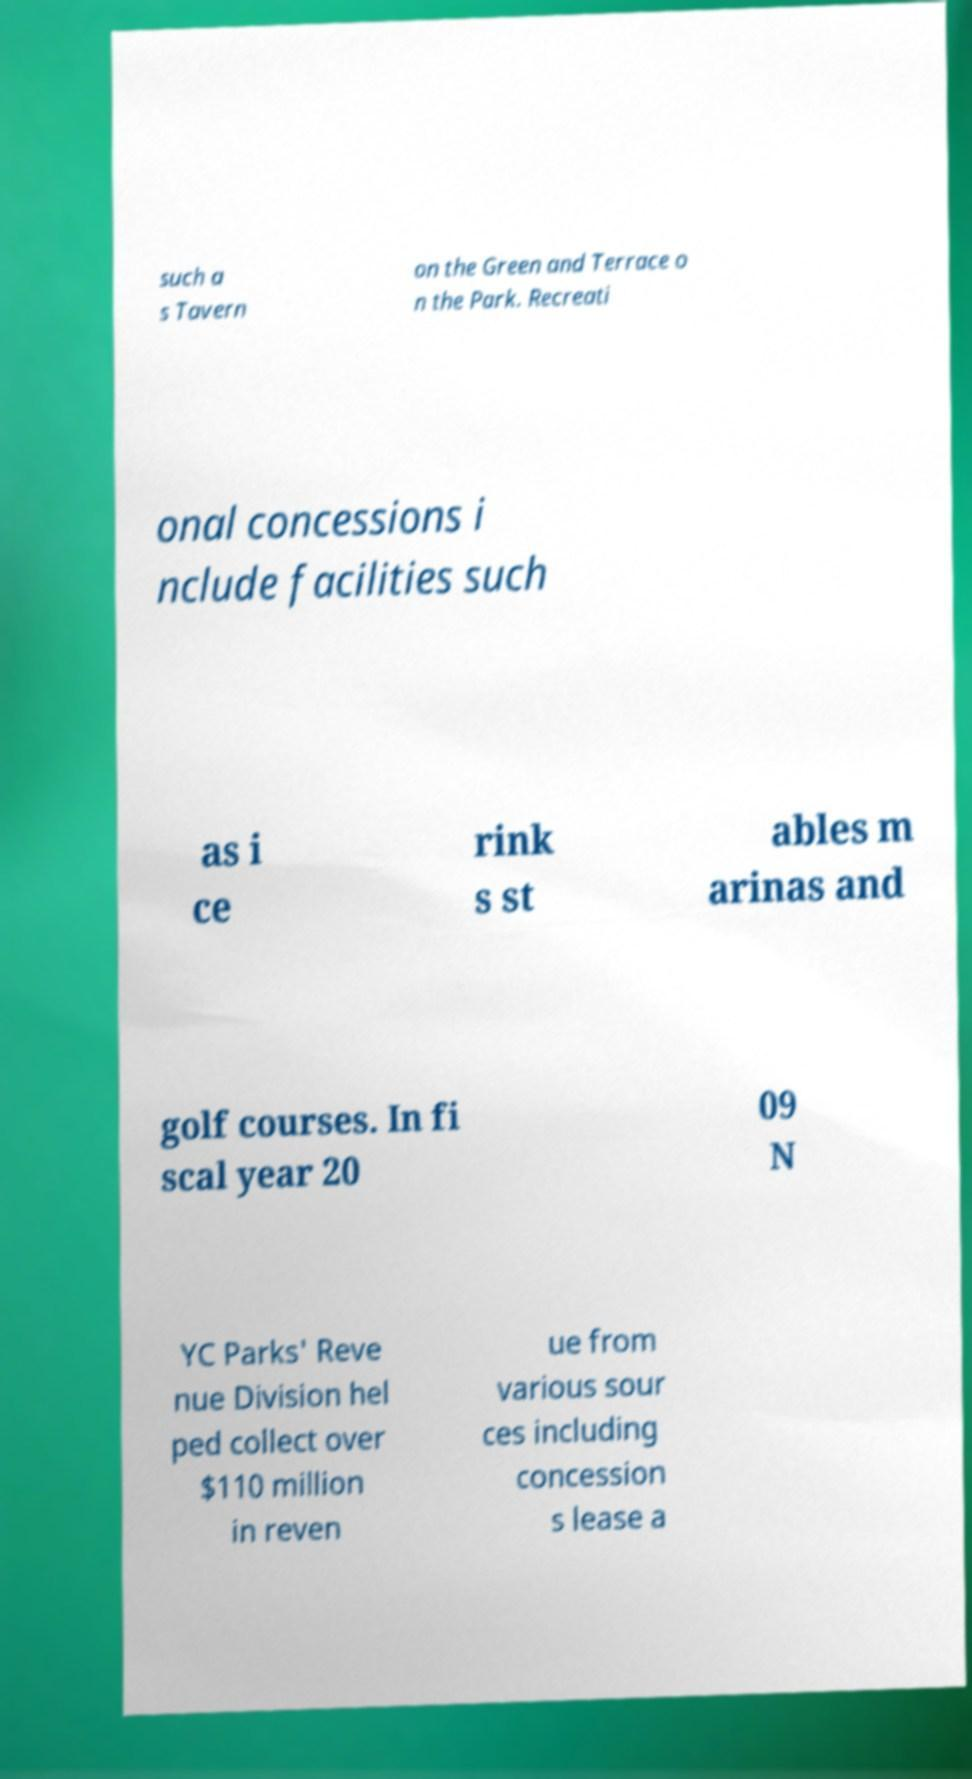Please read and relay the text visible in this image. What does it say? such a s Tavern on the Green and Terrace o n the Park. Recreati onal concessions i nclude facilities such as i ce rink s st ables m arinas and golf courses. In fi scal year 20 09 N YC Parks' Reve nue Division hel ped collect over $110 million in reven ue from various sour ces including concession s lease a 